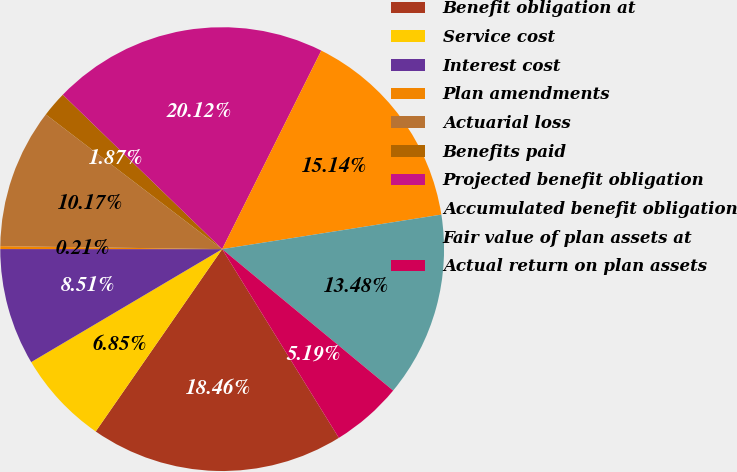<chart> <loc_0><loc_0><loc_500><loc_500><pie_chart><fcel>Benefit obligation at<fcel>Service cost<fcel>Interest cost<fcel>Plan amendments<fcel>Actuarial loss<fcel>Benefits paid<fcel>Projected benefit obligation<fcel>Accumulated benefit obligation<fcel>Fair value of plan assets at<fcel>Actual return on plan assets<nl><fcel>18.47%<fcel>6.85%<fcel>8.51%<fcel>0.21%<fcel>10.17%<fcel>1.87%<fcel>20.13%<fcel>15.15%<fcel>13.49%<fcel>5.19%<nl></chart> 